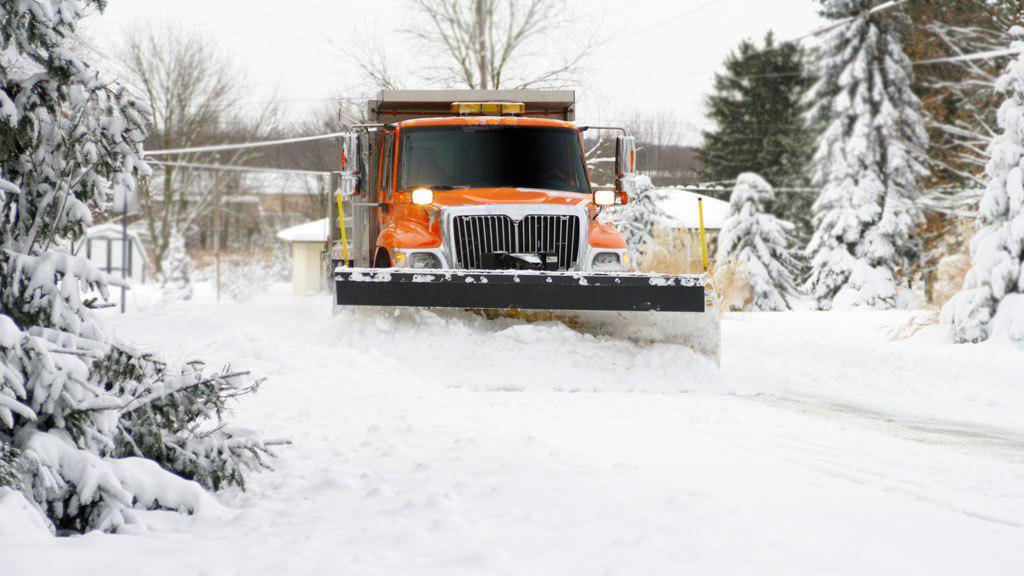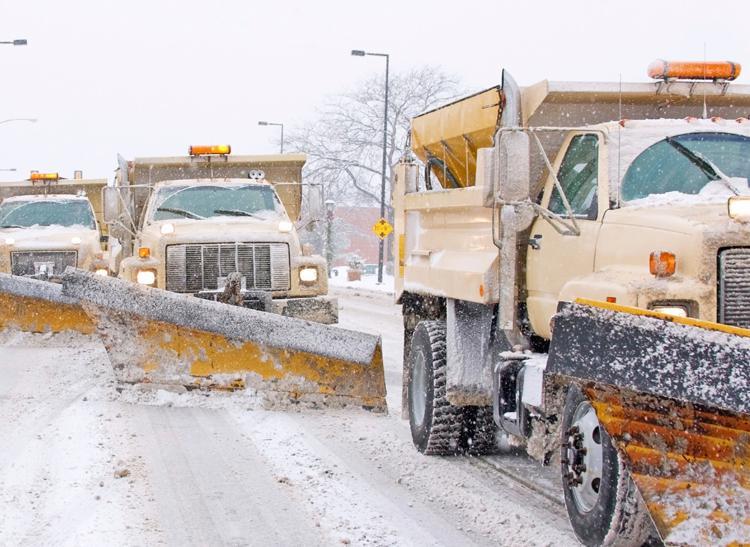The first image is the image on the left, the second image is the image on the right. Given the left and right images, does the statement "An image shows more than one snowplow truck on the same snowy road." hold true? Answer yes or no. Yes. 